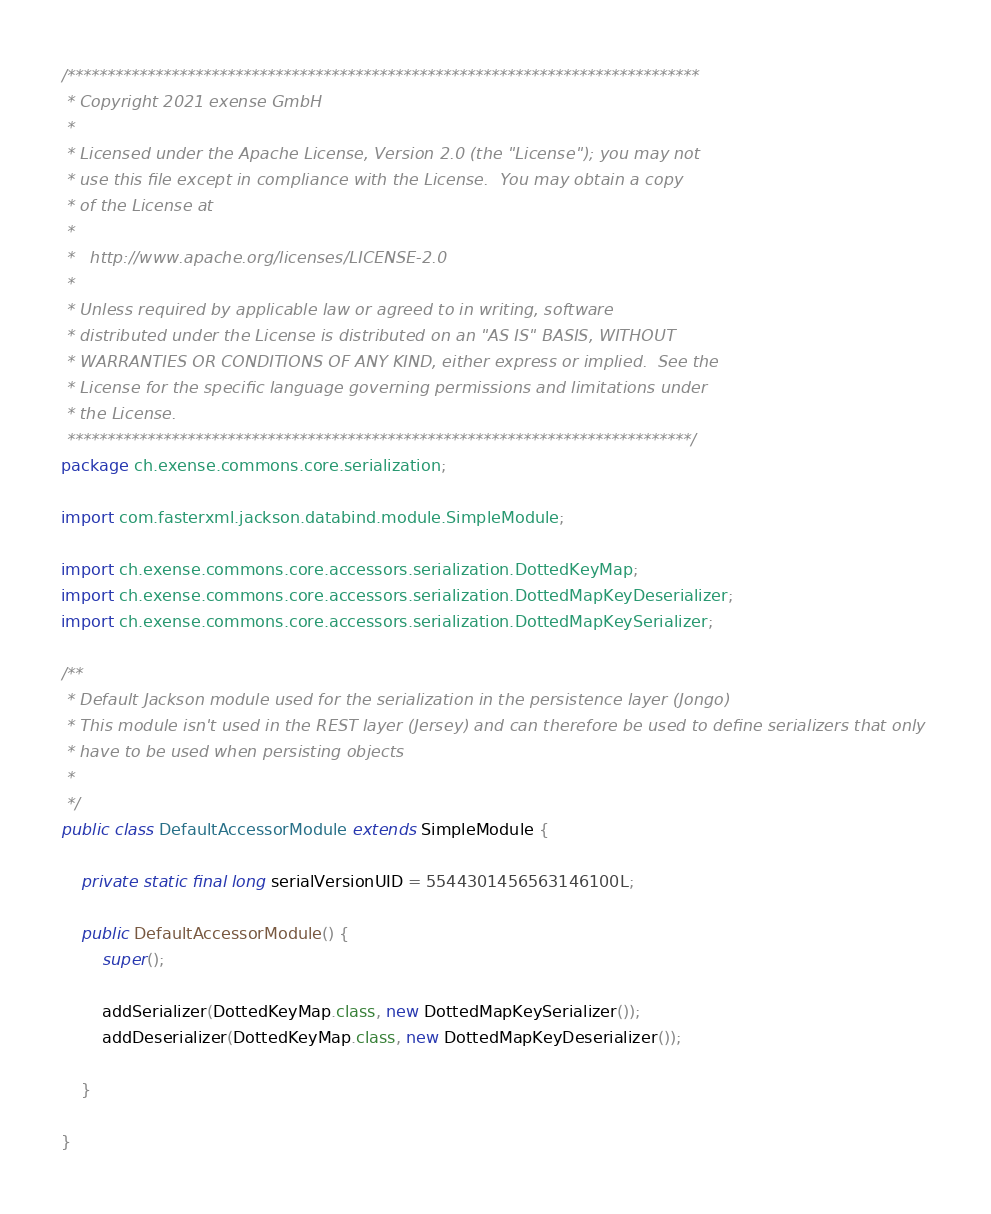Convert code to text. <code><loc_0><loc_0><loc_500><loc_500><_Java_>/*******************************************************************************
 * Copyright 2021 exense GmbH
 * 
 * Licensed under the Apache License, Version 2.0 (the "License"); you may not
 * use this file except in compliance with the License.  You may obtain a copy
 * of the License at
 * 
 *   http://www.apache.org/licenses/LICENSE-2.0
 * 
 * Unless required by applicable law or agreed to in writing, software
 * distributed under the License is distributed on an "AS IS" BASIS, WITHOUT
 * WARRANTIES OR CONDITIONS OF ANY KIND, either express or implied.  See the
 * License for the specific language governing permissions and limitations under
 * the License.
 ******************************************************************************/
package ch.exense.commons.core.serialization;

import com.fasterxml.jackson.databind.module.SimpleModule;

import ch.exense.commons.core.accessors.serialization.DottedKeyMap;
import ch.exense.commons.core.accessors.serialization.DottedMapKeyDeserializer;
import ch.exense.commons.core.accessors.serialization.DottedMapKeySerializer;

/**
 * Default Jackson module used for the serialization in the persistence layer (Jongo)
 * This module isn't used in the REST layer (Jersey) and can therefore be used to define serializers that only 
 * have to be used when persisting objects
 * 
 */
public class DefaultAccessorModule extends SimpleModule {

	private static final long serialVersionUID = 5544301456563146100L;

	public DefaultAccessorModule() {
		super();
		
		addSerializer(DottedKeyMap.class, new DottedMapKeySerializer());
		addDeserializer(DottedKeyMap.class, new DottedMapKeyDeserializer());
		
	}

}
</code> 